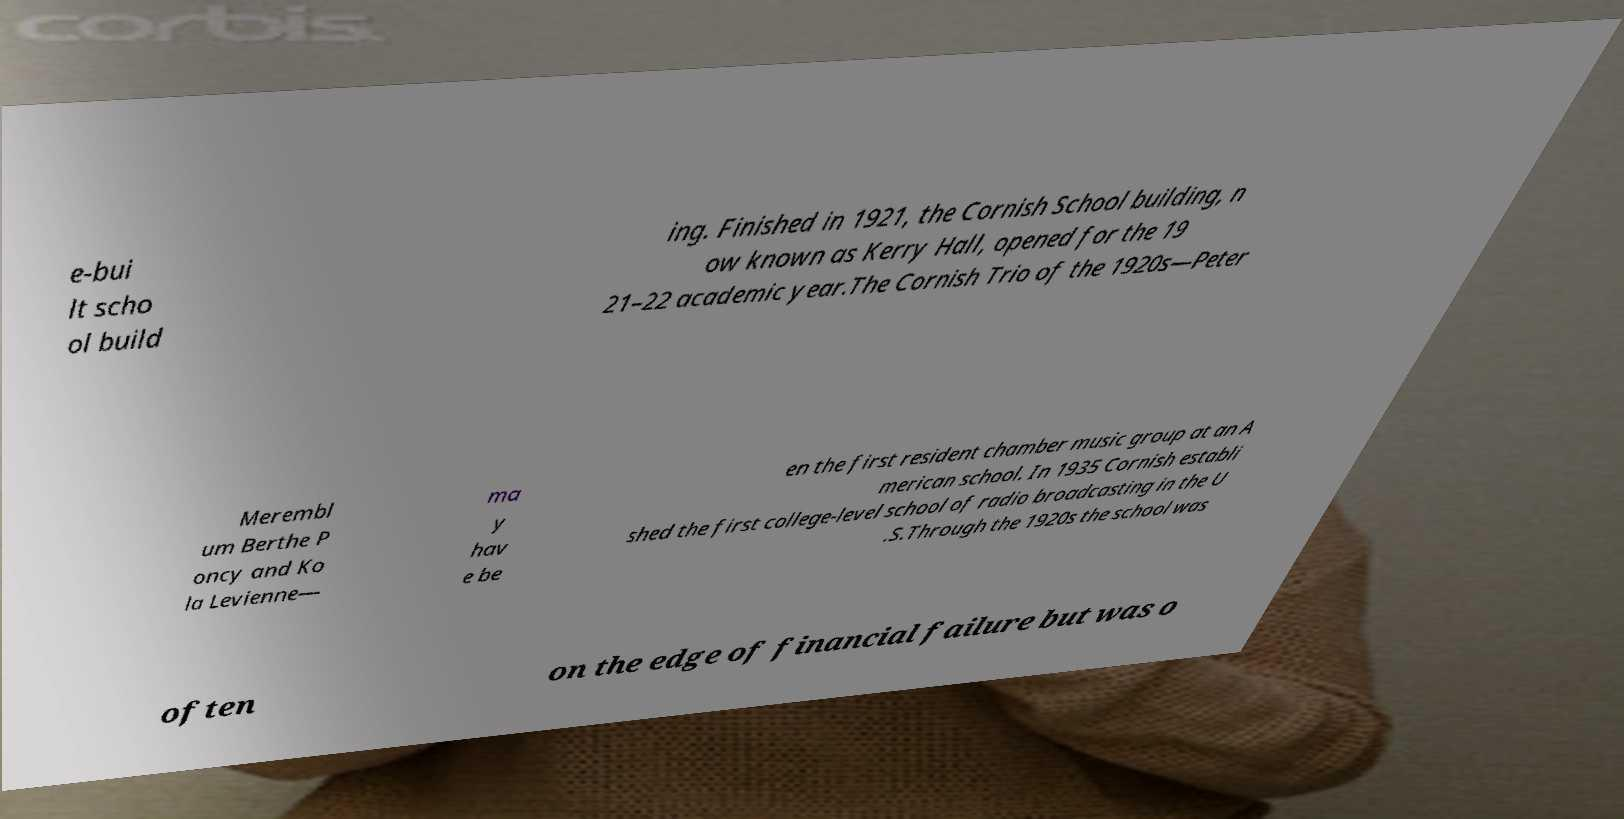Please identify and transcribe the text found in this image. e-bui lt scho ol build ing. Finished in 1921, the Cornish School building, n ow known as Kerry Hall, opened for the 19 21–22 academic year.The Cornish Trio of the 1920s—Peter Merembl um Berthe P oncy and Ko la Levienne— ma y hav e be en the first resident chamber music group at an A merican school. In 1935 Cornish establi shed the first college-level school of radio broadcasting in the U .S.Through the 1920s the school was often on the edge of financial failure but was o 